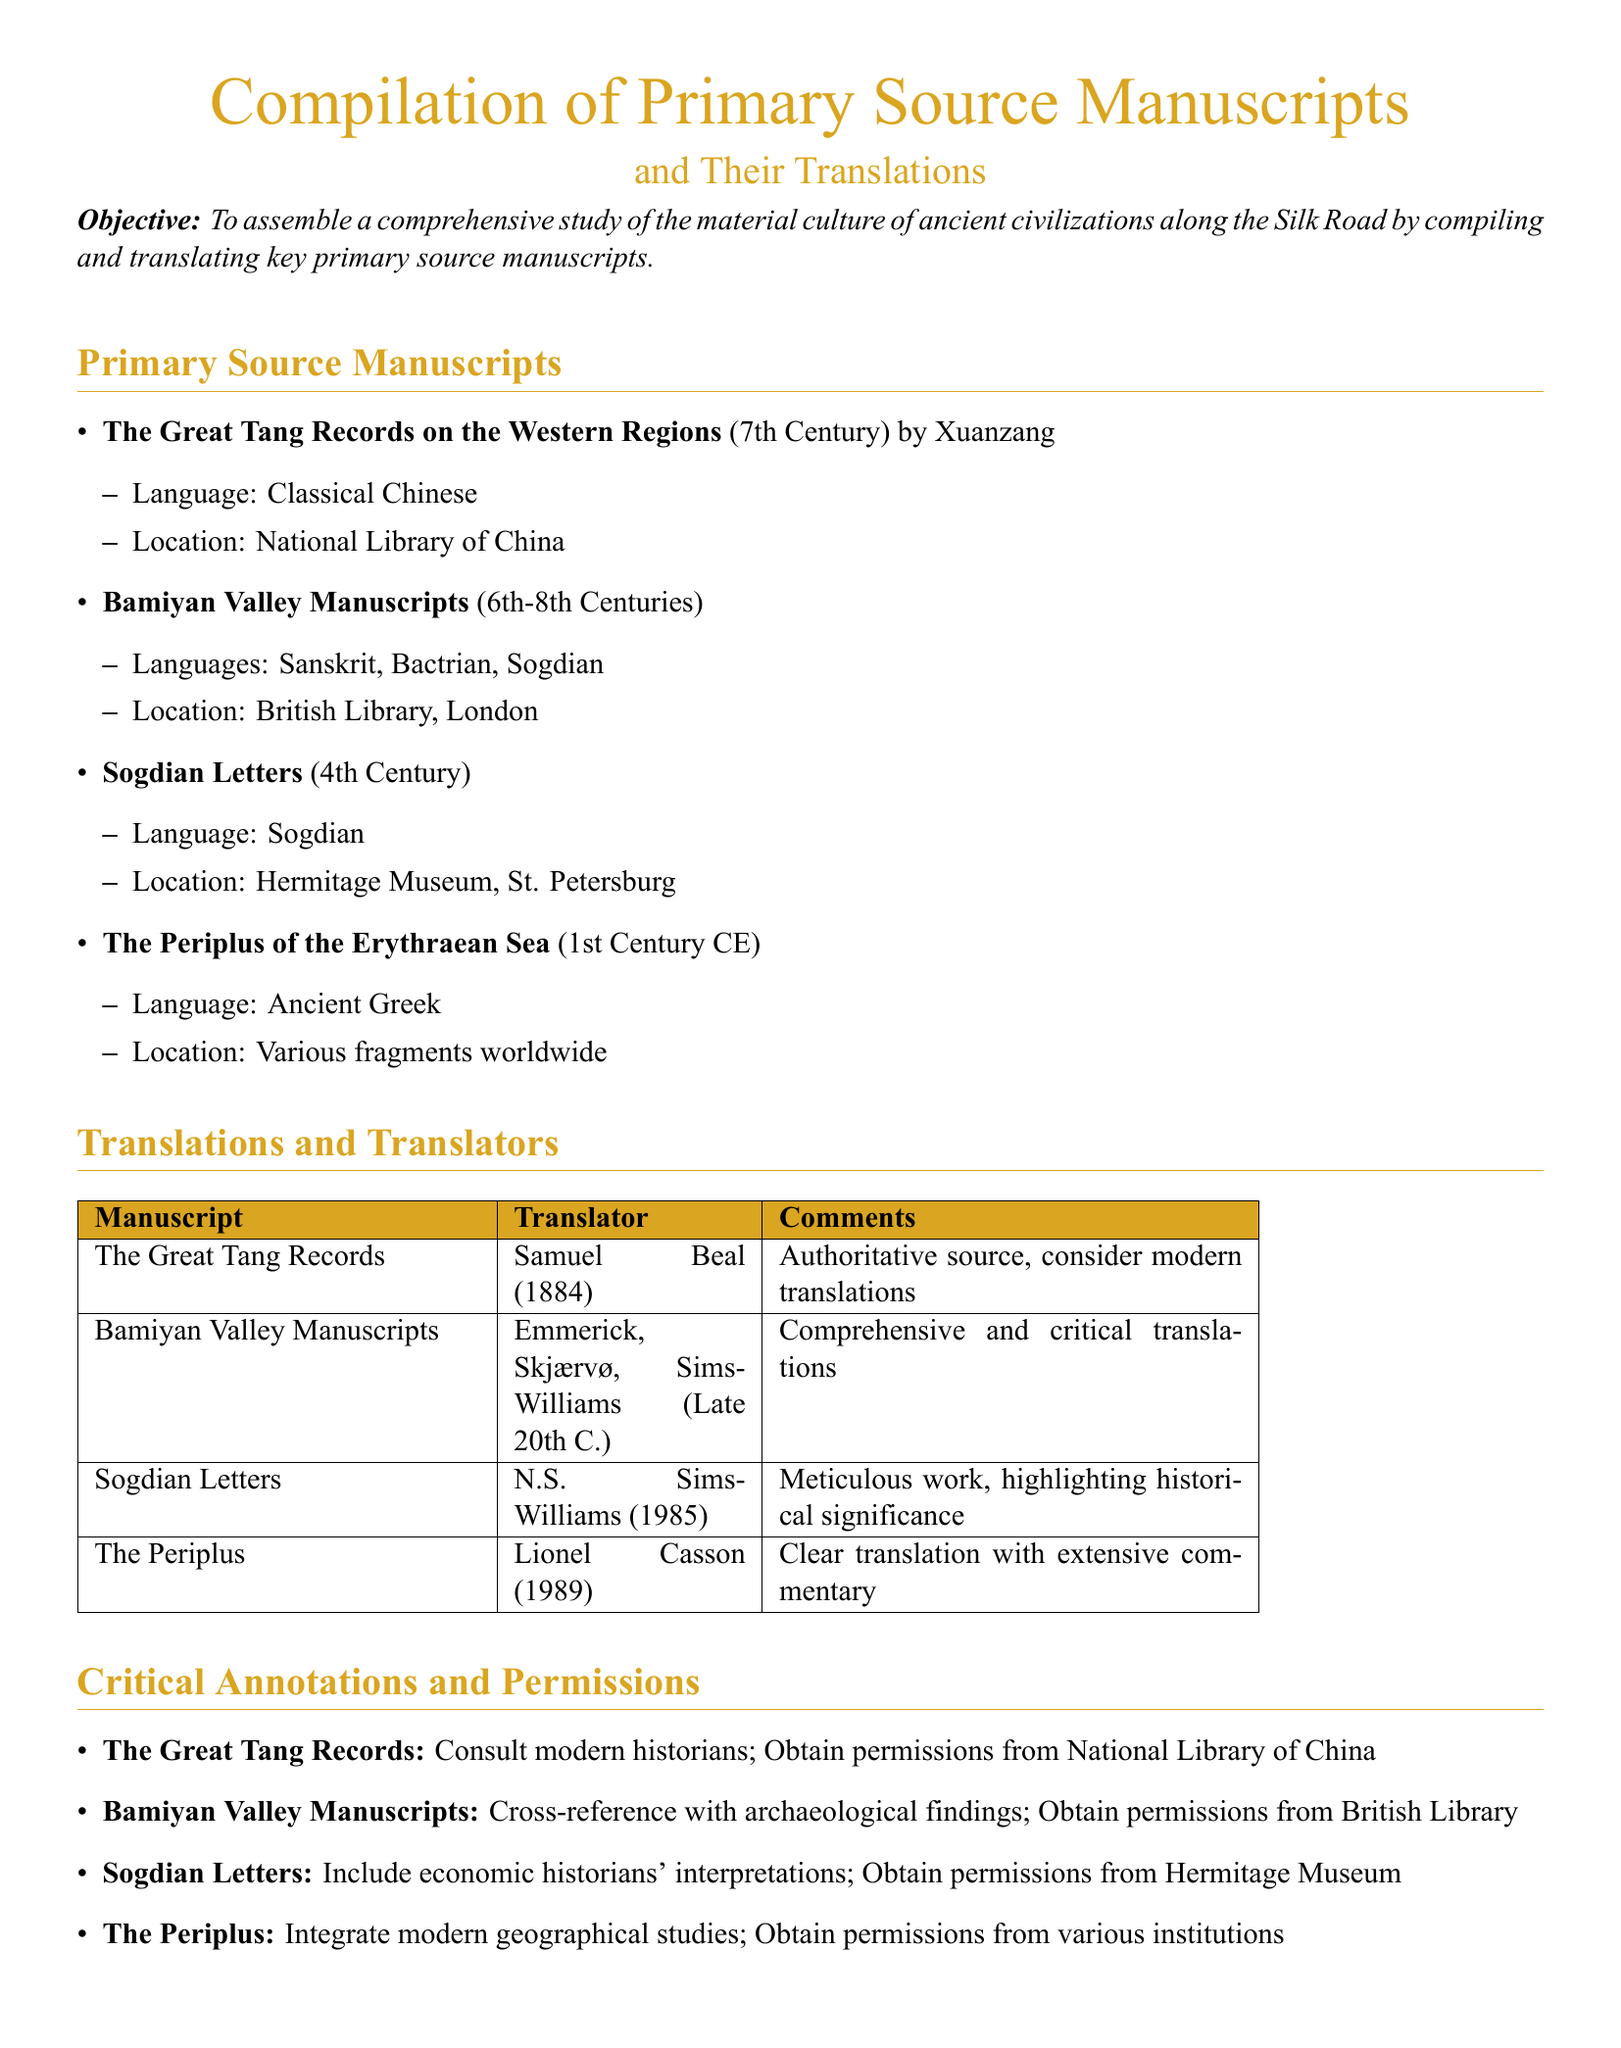What is the main objective of the document? The main objective is stated at the beginning, which is to assemble a comprehensive study of material culture along the Silk Road.
Answer: To assemble a comprehensive study of the material culture of ancient civilizations along the Silk Road Who authored "The Great Tang Records on the Western Regions"? The author of this manuscript is mentioned explicitly in the document.
Answer: Xuanzang In what language is the "Sogdian Letters" manuscript written? The language is specified next to the manuscript title in the document.
Answer: Sogdian Which museum holds the Bamiyan Valley Manuscripts? The location of these manuscripts is stated in the corresponding section of the document.
Answer: British Library, London Who translated "The Periplus of the Erythraean Sea"? The translator is listed in the translations table in the document.
Answer: Lionel Casson What century does "The Periplus of the Erythraean Sea" belong to? The document provides a date for the manuscript.
Answer: 1st Century CE What should be integrated with "The Periplus" translations according to the critical annotations? The document outlines what should be considered in the critical annotations section.
Answer: Modern geographical studies How many translators are mentioned for the Bamiyan Valley Manuscripts? The number of translators is deduced from the entry in the translations table.
Answer: Three What is a recommended action regarding the "Great Tang Records"? This action is noted under the critical annotations for this manuscript in the document.
Answer: Obtain permissions from National Library of China 